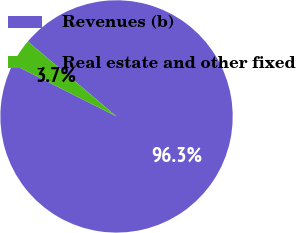Convert chart. <chart><loc_0><loc_0><loc_500><loc_500><pie_chart><fcel>Revenues (b)<fcel>Real estate and other fixed<nl><fcel>96.27%<fcel>3.73%<nl></chart> 